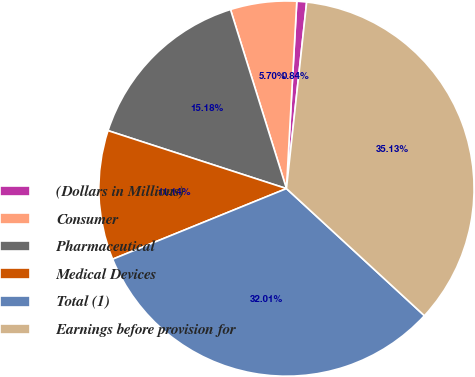<chart> <loc_0><loc_0><loc_500><loc_500><pie_chart><fcel>(Dollars in Millions)<fcel>Consumer<fcel>Pharmaceutical<fcel>Medical Devices<fcel>Total (1)<fcel>Earnings before provision for<nl><fcel>0.84%<fcel>5.7%<fcel>15.18%<fcel>11.14%<fcel>32.01%<fcel>35.13%<nl></chart> 